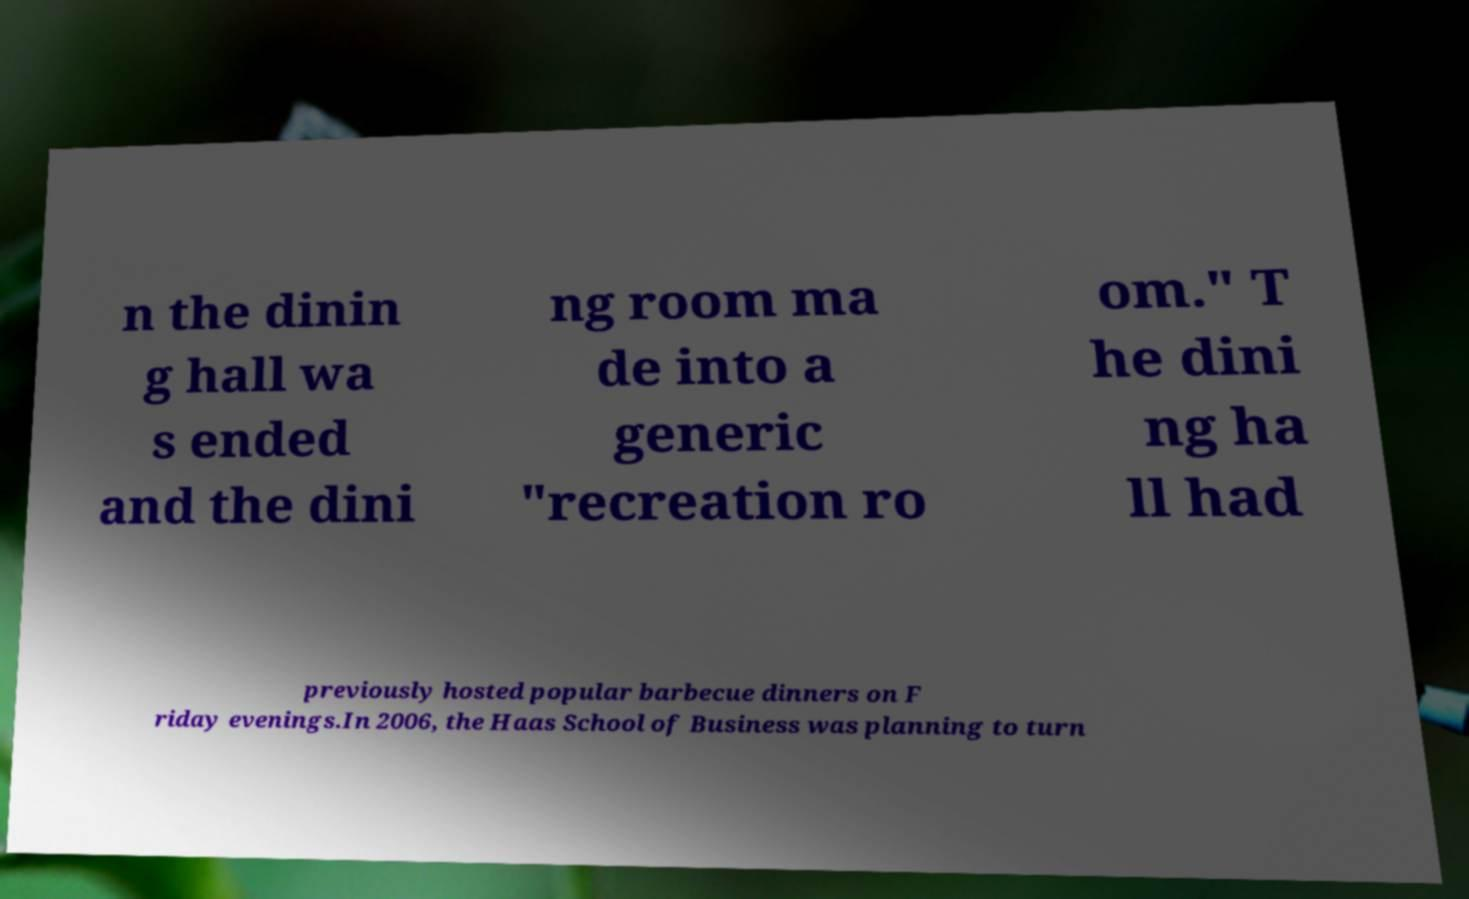Could you extract and type out the text from this image? n the dinin g hall wa s ended and the dini ng room ma de into a generic "recreation ro om." T he dini ng ha ll had previously hosted popular barbecue dinners on F riday evenings.In 2006, the Haas School of Business was planning to turn 